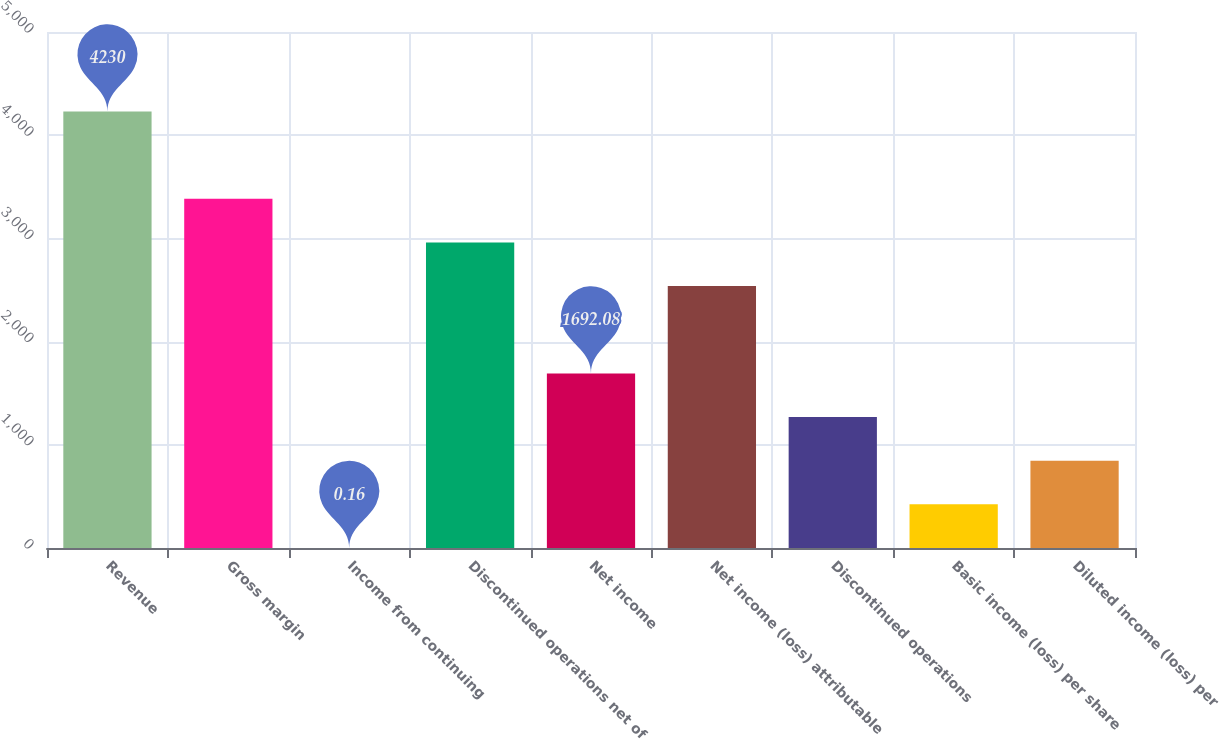Convert chart to OTSL. <chart><loc_0><loc_0><loc_500><loc_500><bar_chart><fcel>Revenue<fcel>Gross margin<fcel>Income from continuing<fcel>Discontinued operations net of<fcel>Net income<fcel>Net income (loss) attributable<fcel>Discontinued operations<fcel>Basic income (loss) per share<fcel>Diluted income (loss) per<nl><fcel>4230<fcel>3384<fcel>0.16<fcel>2961.02<fcel>1692.08<fcel>2538.04<fcel>1269.1<fcel>423.14<fcel>846.12<nl></chart> 